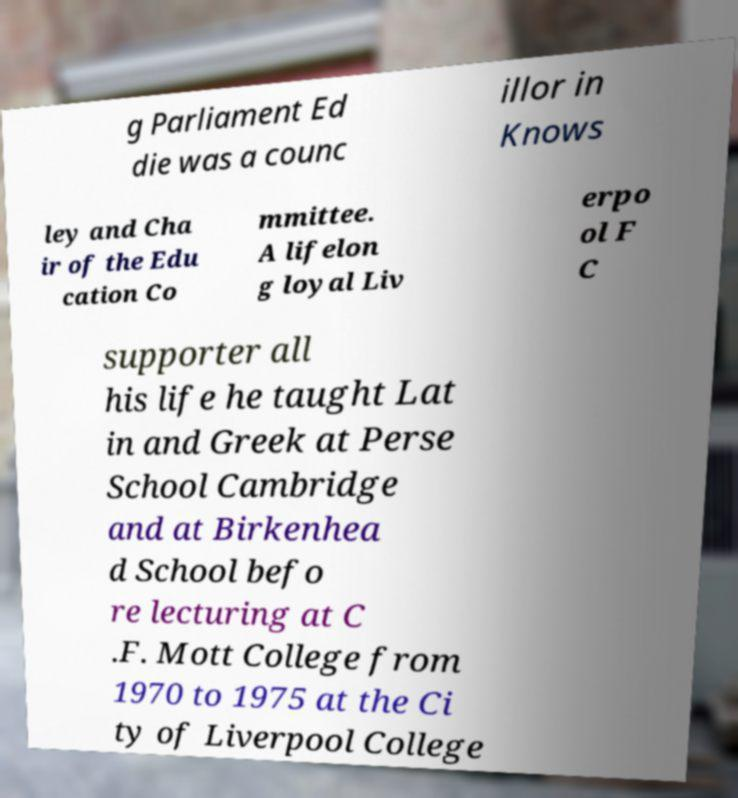Can you read and provide the text displayed in the image?This photo seems to have some interesting text. Can you extract and type it out for me? g Parliament Ed die was a counc illor in Knows ley and Cha ir of the Edu cation Co mmittee. A lifelon g loyal Liv erpo ol F C supporter all his life he taught Lat in and Greek at Perse School Cambridge and at Birkenhea d School befo re lecturing at C .F. Mott College from 1970 to 1975 at the Ci ty of Liverpool College 